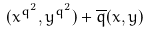<formula> <loc_0><loc_0><loc_500><loc_500>( x ^ { q ^ { 2 } } , y ^ { q ^ { 2 } } ) + \overline { q } ( x , y )</formula> 